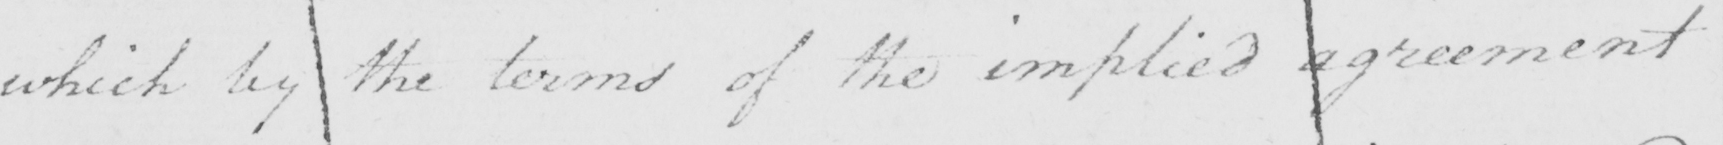Please provide the text content of this handwritten line. which by the terms of the implied agreement 